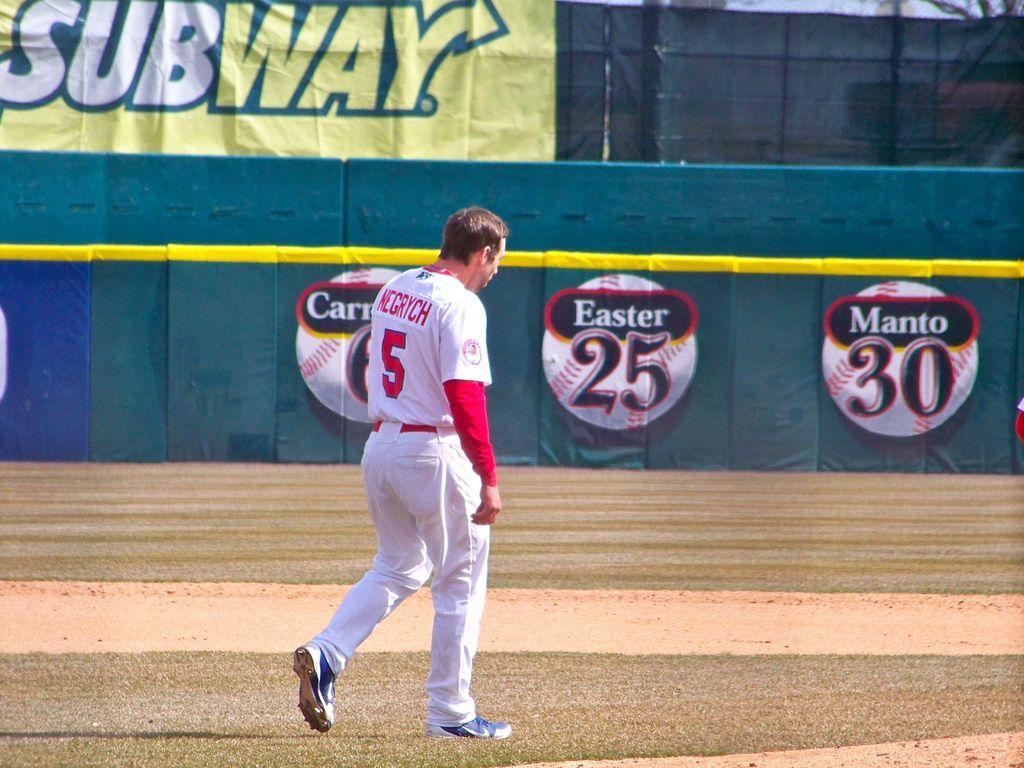Please provide a concise description of this image. In this image there is a person walking on the ground, in front of him there are banners on the boundary fence with sponsor names. 